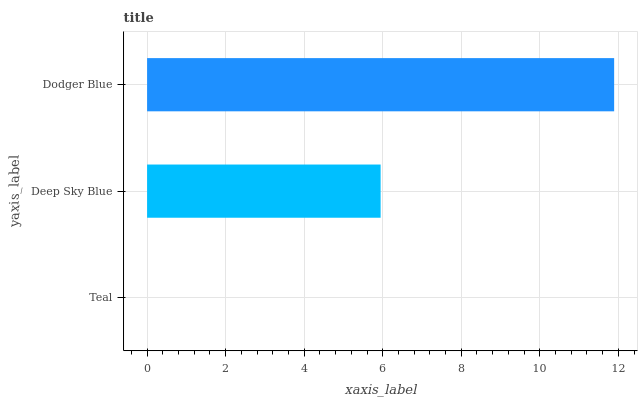Is Teal the minimum?
Answer yes or no. Yes. Is Dodger Blue the maximum?
Answer yes or no. Yes. Is Deep Sky Blue the minimum?
Answer yes or no. No. Is Deep Sky Blue the maximum?
Answer yes or no. No. Is Deep Sky Blue greater than Teal?
Answer yes or no. Yes. Is Teal less than Deep Sky Blue?
Answer yes or no. Yes. Is Teal greater than Deep Sky Blue?
Answer yes or no. No. Is Deep Sky Blue less than Teal?
Answer yes or no. No. Is Deep Sky Blue the high median?
Answer yes or no. Yes. Is Deep Sky Blue the low median?
Answer yes or no. Yes. Is Teal the high median?
Answer yes or no. No. Is Teal the low median?
Answer yes or no. No. 